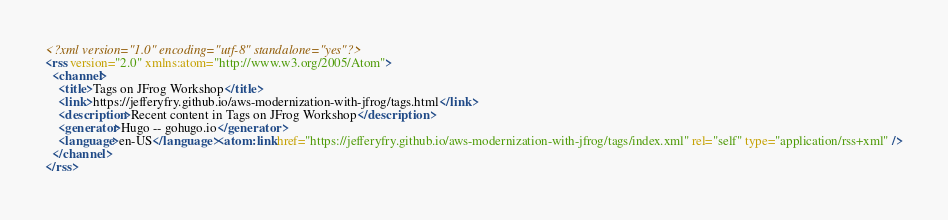<code> <loc_0><loc_0><loc_500><loc_500><_XML_><?xml version="1.0" encoding="utf-8" standalone="yes"?>
<rss version="2.0" xmlns:atom="http://www.w3.org/2005/Atom">
  <channel>
    <title>Tags on JFrog Workshop</title>
    <link>https://jefferyfry.github.io/aws-modernization-with-jfrog/tags.html</link>
    <description>Recent content in Tags on JFrog Workshop</description>
    <generator>Hugo -- gohugo.io</generator>
    <language>en-US</language><atom:link href="https://jefferyfry.github.io/aws-modernization-with-jfrog/tags/index.xml" rel="self" type="application/rss+xml" />
  </channel>
</rss>
</code> 